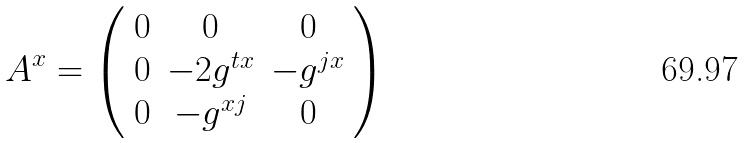<formula> <loc_0><loc_0><loc_500><loc_500>A ^ { x } = \left ( \begin{array} { c c c } 0 & 0 & 0 \\ 0 & - 2 g ^ { t x } & - g ^ { j x } \\ 0 & - g ^ { x j } & 0 \end{array} \right )</formula> 